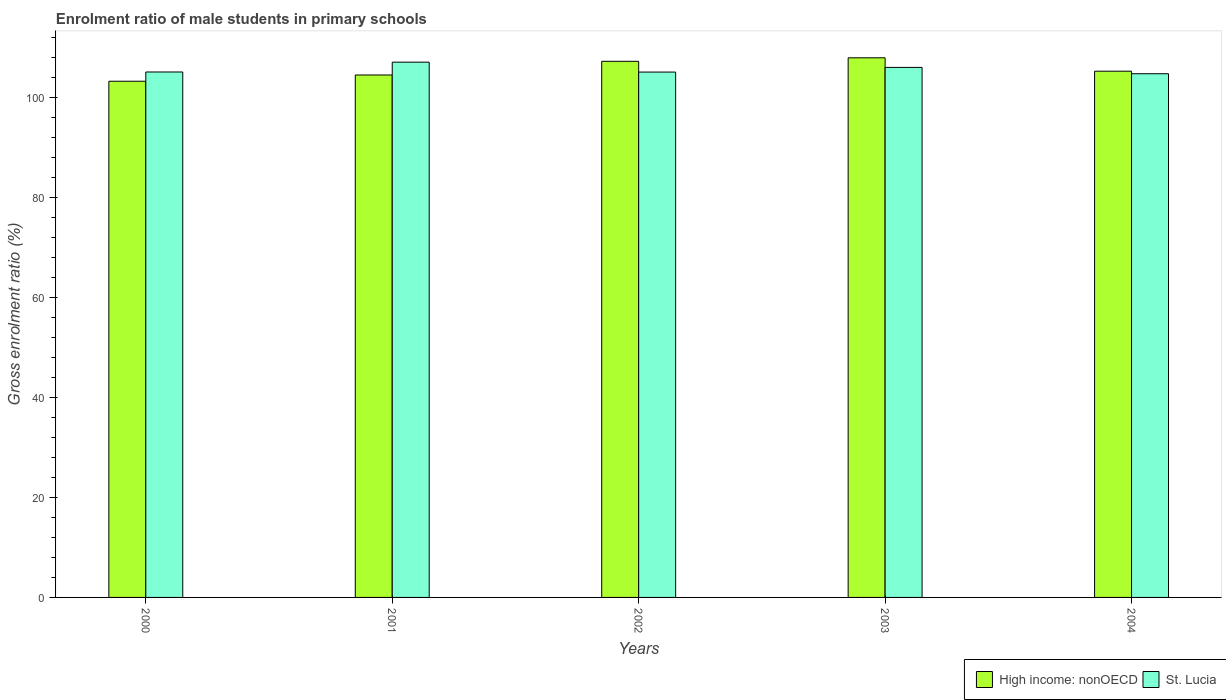How many groups of bars are there?
Your answer should be compact. 5. Are the number of bars per tick equal to the number of legend labels?
Your answer should be very brief. Yes. What is the enrolment ratio of male students in primary schools in High income: nonOECD in 2000?
Provide a short and direct response. 103.26. Across all years, what is the maximum enrolment ratio of male students in primary schools in High income: nonOECD?
Ensure brevity in your answer.  107.95. Across all years, what is the minimum enrolment ratio of male students in primary schools in High income: nonOECD?
Make the answer very short. 103.26. In which year was the enrolment ratio of male students in primary schools in High income: nonOECD minimum?
Provide a succinct answer. 2000. What is the total enrolment ratio of male students in primary schools in High income: nonOECD in the graph?
Give a very brief answer. 528.25. What is the difference between the enrolment ratio of male students in primary schools in St. Lucia in 2003 and that in 2004?
Offer a very short reply. 1.27. What is the difference between the enrolment ratio of male students in primary schools in High income: nonOECD in 2003 and the enrolment ratio of male students in primary schools in St. Lucia in 2002?
Offer a terse response. 2.85. What is the average enrolment ratio of male students in primary schools in High income: nonOECD per year?
Ensure brevity in your answer.  105.65. In the year 2003, what is the difference between the enrolment ratio of male students in primary schools in St. Lucia and enrolment ratio of male students in primary schools in High income: nonOECD?
Offer a very short reply. -1.92. What is the ratio of the enrolment ratio of male students in primary schools in St. Lucia in 2000 to that in 2004?
Your answer should be compact. 1. What is the difference between the highest and the second highest enrolment ratio of male students in primary schools in St. Lucia?
Make the answer very short. 1.05. What is the difference between the highest and the lowest enrolment ratio of male students in primary schools in St. Lucia?
Give a very brief answer. 2.32. What does the 1st bar from the left in 2002 represents?
Your answer should be compact. High income: nonOECD. What does the 1st bar from the right in 2001 represents?
Ensure brevity in your answer.  St. Lucia. How many bars are there?
Provide a short and direct response. 10. How many years are there in the graph?
Your answer should be compact. 5. Are the values on the major ticks of Y-axis written in scientific E-notation?
Offer a terse response. No. How many legend labels are there?
Keep it short and to the point. 2. What is the title of the graph?
Offer a terse response. Enrolment ratio of male students in primary schools. Does "Nicaragua" appear as one of the legend labels in the graph?
Your answer should be very brief. No. What is the label or title of the X-axis?
Keep it short and to the point. Years. What is the label or title of the Y-axis?
Provide a succinct answer. Gross enrolment ratio (%). What is the Gross enrolment ratio (%) of High income: nonOECD in 2000?
Keep it short and to the point. 103.26. What is the Gross enrolment ratio (%) of St. Lucia in 2000?
Give a very brief answer. 105.11. What is the Gross enrolment ratio (%) in High income: nonOECD in 2001?
Keep it short and to the point. 104.51. What is the Gross enrolment ratio (%) in St. Lucia in 2001?
Your answer should be very brief. 107.08. What is the Gross enrolment ratio (%) in High income: nonOECD in 2002?
Offer a terse response. 107.25. What is the Gross enrolment ratio (%) of St. Lucia in 2002?
Provide a short and direct response. 105.1. What is the Gross enrolment ratio (%) in High income: nonOECD in 2003?
Make the answer very short. 107.95. What is the Gross enrolment ratio (%) in St. Lucia in 2003?
Your answer should be very brief. 106.03. What is the Gross enrolment ratio (%) in High income: nonOECD in 2004?
Offer a very short reply. 105.27. What is the Gross enrolment ratio (%) of St. Lucia in 2004?
Offer a terse response. 104.77. Across all years, what is the maximum Gross enrolment ratio (%) of High income: nonOECD?
Make the answer very short. 107.95. Across all years, what is the maximum Gross enrolment ratio (%) in St. Lucia?
Provide a short and direct response. 107.08. Across all years, what is the minimum Gross enrolment ratio (%) in High income: nonOECD?
Offer a very short reply. 103.26. Across all years, what is the minimum Gross enrolment ratio (%) in St. Lucia?
Your answer should be very brief. 104.77. What is the total Gross enrolment ratio (%) in High income: nonOECD in the graph?
Your response must be concise. 528.25. What is the total Gross enrolment ratio (%) of St. Lucia in the graph?
Make the answer very short. 528.09. What is the difference between the Gross enrolment ratio (%) in High income: nonOECD in 2000 and that in 2001?
Give a very brief answer. -1.25. What is the difference between the Gross enrolment ratio (%) in St. Lucia in 2000 and that in 2001?
Your answer should be compact. -1.97. What is the difference between the Gross enrolment ratio (%) of High income: nonOECD in 2000 and that in 2002?
Make the answer very short. -3.99. What is the difference between the Gross enrolment ratio (%) of St. Lucia in 2000 and that in 2002?
Your answer should be very brief. 0.02. What is the difference between the Gross enrolment ratio (%) of High income: nonOECD in 2000 and that in 2003?
Offer a very short reply. -4.69. What is the difference between the Gross enrolment ratio (%) of St. Lucia in 2000 and that in 2003?
Provide a short and direct response. -0.92. What is the difference between the Gross enrolment ratio (%) of High income: nonOECD in 2000 and that in 2004?
Provide a succinct answer. -2.01. What is the difference between the Gross enrolment ratio (%) in St. Lucia in 2000 and that in 2004?
Offer a terse response. 0.35. What is the difference between the Gross enrolment ratio (%) in High income: nonOECD in 2001 and that in 2002?
Provide a short and direct response. -2.74. What is the difference between the Gross enrolment ratio (%) in St. Lucia in 2001 and that in 2002?
Your answer should be compact. 1.98. What is the difference between the Gross enrolment ratio (%) of High income: nonOECD in 2001 and that in 2003?
Offer a very short reply. -3.44. What is the difference between the Gross enrolment ratio (%) in St. Lucia in 2001 and that in 2003?
Offer a terse response. 1.05. What is the difference between the Gross enrolment ratio (%) in High income: nonOECD in 2001 and that in 2004?
Offer a very short reply. -0.76. What is the difference between the Gross enrolment ratio (%) in St. Lucia in 2001 and that in 2004?
Keep it short and to the point. 2.32. What is the difference between the Gross enrolment ratio (%) of High income: nonOECD in 2002 and that in 2003?
Your answer should be compact. -0.7. What is the difference between the Gross enrolment ratio (%) of St. Lucia in 2002 and that in 2003?
Offer a terse response. -0.94. What is the difference between the Gross enrolment ratio (%) of High income: nonOECD in 2002 and that in 2004?
Offer a very short reply. 1.98. What is the difference between the Gross enrolment ratio (%) in St. Lucia in 2002 and that in 2004?
Offer a very short reply. 0.33. What is the difference between the Gross enrolment ratio (%) of High income: nonOECD in 2003 and that in 2004?
Keep it short and to the point. 2.68. What is the difference between the Gross enrolment ratio (%) of St. Lucia in 2003 and that in 2004?
Your answer should be very brief. 1.27. What is the difference between the Gross enrolment ratio (%) of High income: nonOECD in 2000 and the Gross enrolment ratio (%) of St. Lucia in 2001?
Ensure brevity in your answer.  -3.82. What is the difference between the Gross enrolment ratio (%) of High income: nonOECD in 2000 and the Gross enrolment ratio (%) of St. Lucia in 2002?
Your answer should be very brief. -1.83. What is the difference between the Gross enrolment ratio (%) of High income: nonOECD in 2000 and the Gross enrolment ratio (%) of St. Lucia in 2003?
Offer a terse response. -2.77. What is the difference between the Gross enrolment ratio (%) in High income: nonOECD in 2000 and the Gross enrolment ratio (%) in St. Lucia in 2004?
Give a very brief answer. -1.5. What is the difference between the Gross enrolment ratio (%) in High income: nonOECD in 2001 and the Gross enrolment ratio (%) in St. Lucia in 2002?
Offer a terse response. -0.58. What is the difference between the Gross enrolment ratio (%) of High income: nonOECD in 2001 and the Gross enrolment ratio (%) of St. Lucia in 2003?
Offer a very short reply. -1.52. What is the difference between the Gross enrolment ratio (%) of High income: nonOECD in 2001 and the Gross enrolment ratio (%) of St. Lucia in 2004?
Provide a short and direct response. -0.25. What is the difference between the Gross enrolment ratio (%) of High income: nonOECD in 2002 and the Gross enrolment ratio (%) of St. Lucia in 2003?
Your answer should be compact. 1.22. What is the difference between the Gross enrolment ratio (%) in High income: nonOECD in 2002 and the Gross enrolment ratio (%) in St. Lucia in 2004?
Keep it short and to the point. 2.48. What is the difference between the Gross enrolment ratio (%) in High income: nonOECD in 2003 and the Gross enrolment ratio (%) in St. Lucia in 2004?
Your answer should be very brief. 3.19. What is the average Gross enrolment ratio (%) of High income: nonOECD per year?
Your answer should be very brief. 105.65. What is the average Gross enrolment ratio (%) in St. Lucia per year?
Your response must be concise. 105.62. In the year 2000, what is the difference between the Gross enrolment ratio (%) of High income: nonOECD and Gross enrolment ratio (%) of St. Lucia?
Make the answer very short. -1.85. In the year 2001, what is the difference between the Gross enrolment ratio (%) of High income: nonOECD and Gross enrolment ratio (%) of St. Lucia?
Ensure brevity in your answer.  -2.57. In the year 2002, what is the difference between the Gross enrolment ratio (%) in High income: nonOECD and Gross enrolment ratio (%) in St. Lucia?
Provide a succinct answer. 2.15. In the year 2003, what is the difference between the Gross enrolment ratio (%) in High income: nonOECD and Gross enrolment ratio (%) in St. Lucia?
Offer a terse response. 1.92. In the year 2004, what is the difference between the Gross enrolment ratio (%) of High income: nonOECD and Gross enrolment ratio (%) of St. Lucia?
Your response must be concise. 0.51. What is the ratio of the Gross enrolment ratio (%) in St. Lucia in 2000 to that in 2001?
Ensure brevity in your answer.  0.98. What is the ratio of the Gross enrolment ratio (%) in High income: nonOECD in 2000 to that in 2002?
Offer a very short reply. 0.96. What is the ratio of the Gross enrolment ratio (%) of High income: nonOECD in 2000 to that in 2003?
Make the answer very short. 0.96. What is the ratio of the Gross enrolment ratio (%) in St. Lucia in 2000 to that in 2003?
Offer a terse response. 0.99. What is the ratio of the Gross enrolment ratio (%) of High income: nonOECD in 2000 to that in 2004?
Ensure brevity in your answer.  0.98. What is the ratio of the Gross enrolment ratio (%) in High income: nonOECD in 2001 to that in 2002?
Your answer should be very brief. 0.97. What is the ratio of the Gross enrolment ratio (%) of St. Lucia in 2001 to that in 2002?
Make the answer very short. 1.02. What is the ratio of the Gross enrolment ratio (%) of High income: nonOECD in 2001 to that in 2003?
Provide a succinct answer. 0.97. What is the ratio of the Gross enrolment ratio (%) of St. Lucia in 2001 to that in 2003?
Offer a terse response. 1.01. What is the ratio of the Gross enrolment ratio (%) in High income: nonOECD in 2001 to that in 2004?
Provide a succinct answer. 0.99. What is the ratio of the Gross enrolment ratio (%) in St. Lucia in 2001 to that in 2004?
Give a very brief answer. 1.02. What is the ratio of the Gross enrolment ratio (%) in St. Lucia in 2002 to that in 2003?
Keep it short and to the point. 0.99. What is the ratio of the Gross enrolment ratio (%) in High income: nonOECD in 2002 to that in 2004?
Offer a terse response. 1.02. What is the ratio of the Gross enrolment ratio (%) in High income: nonOECD in 2003 to that in 2004?
Provide a succinct answer. 1.03. What is the ratio of the Gross enrolment ratio (%) in St. Lucia in 2003 to that in 2004?
Give a very brief answer. 1.01. What is the difference between the highest and the second highest Gross enrolment ratio (%) in High income: nonOECD?
Provide a short and direct response. 0.7. What is the difference between the highest and the second highest Gross enrolment ratio (%) of St. Lucia?
Make the answer very short. 1.05. What is the difference between the highest and the lowest Gross enrolment ratio (%) of High income: nonOECD?
Provide a short and direct response. 4.69. What is the difference between the highest and the lowest Gross enrolment ratio (%) of St. Lucia?
Your answer should be compact. 2.32. 